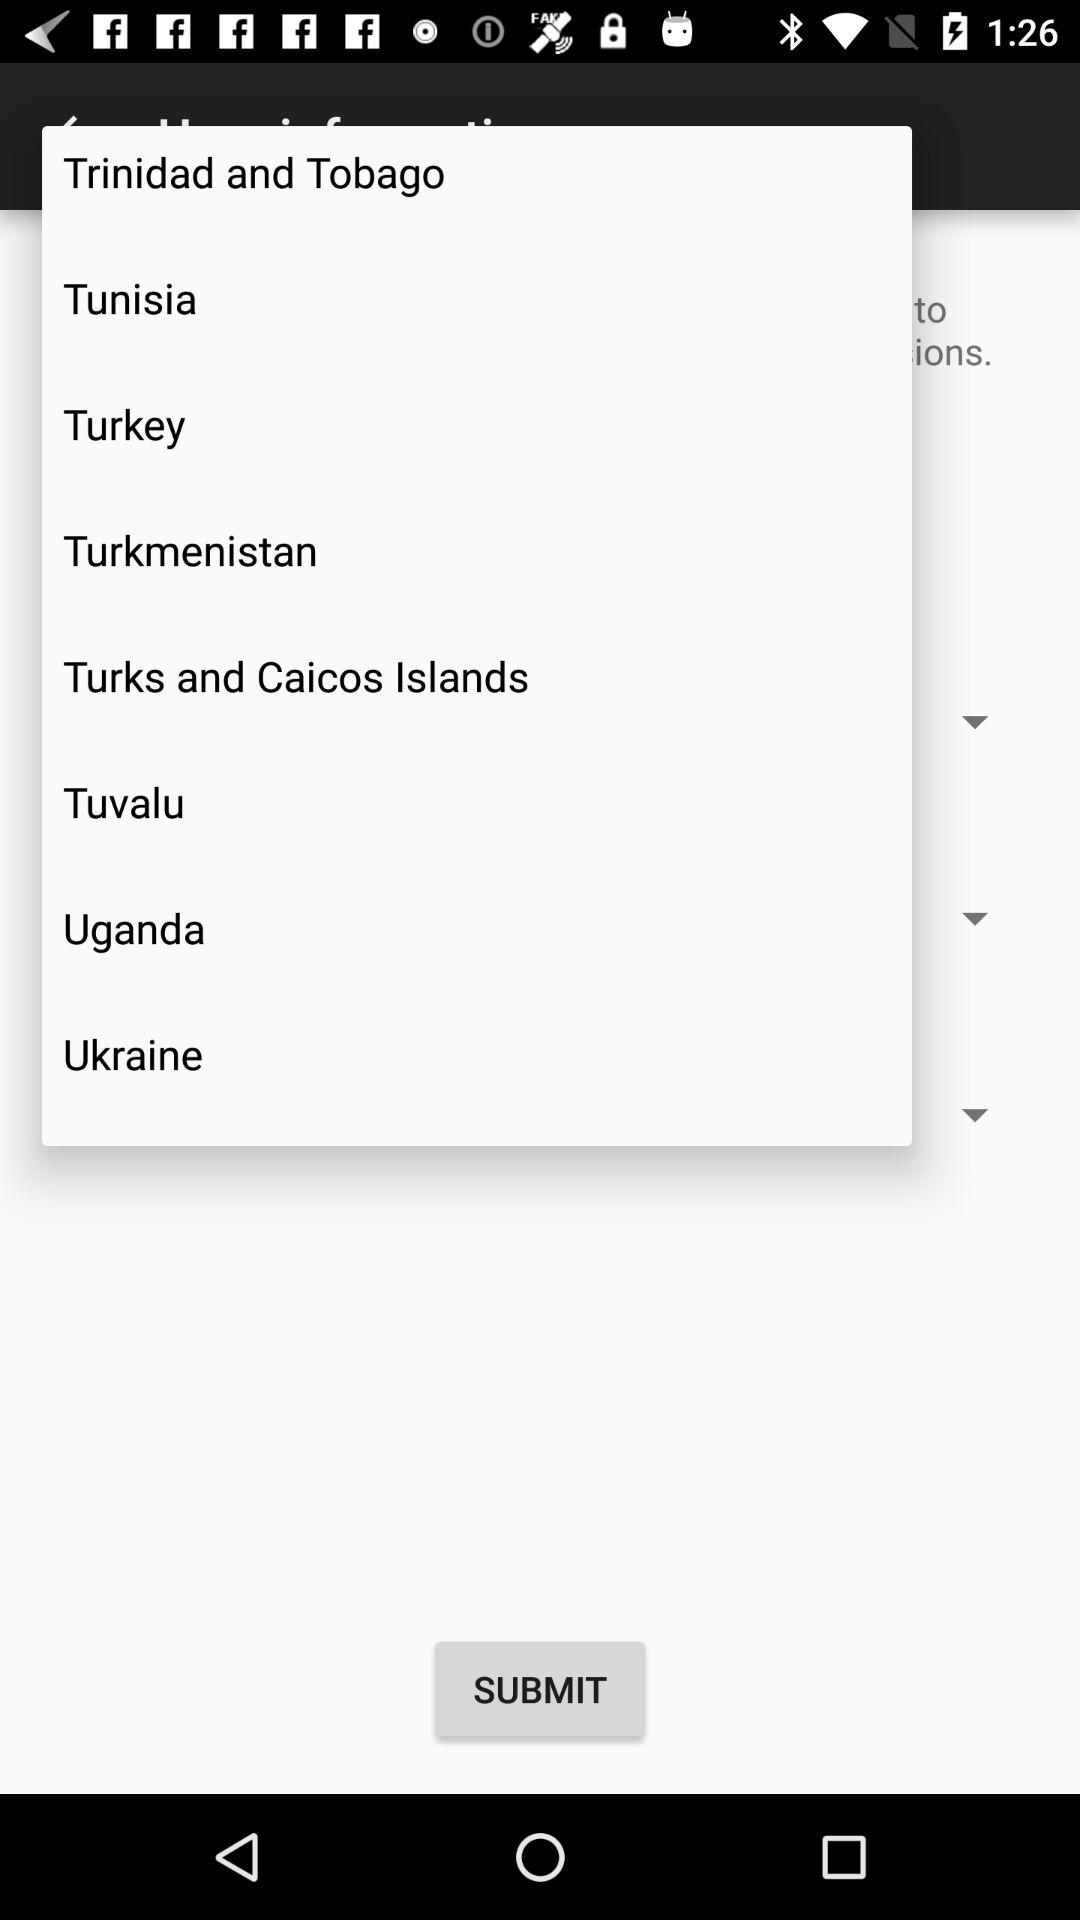Which country is selected?
When the provided information is insufficient, respond with <no answer>. <no answer> 